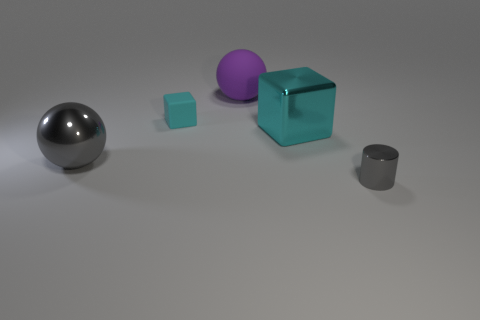Are there fewer yellow rubber balls than big objects?
Your response must be concise. Yes. There is a metal thing behind the gray metal object that is behind the small cylinder; what shape is it?
Offer a terse response. Cube. There is a small thing behind the big ball in front of the big thing that is behind the cyan rubber object; what is its shape?
Keep it short and to the point. Cube. What number of things are either tiny things left of the big purple thing or tiny objects left of the purple object?
Provide a succinct answer. 1. Is the size of the gray metallic cylinder the same as the metal thing left of the cyan matte block?
Your response must be concise. No. Is the large ball that is on the right side of the rubber block made of the same material as the cyan thing that is right of the purple matte ball?
Give a very brief answer. No. Are there an equal number of big spheres that are behind the large matte object and gray objects that are right of the small matte cube?
Provide a short and direct response. No. How many shiny cubes are the same color as the tiny rubber cube?
Make the answer very short. 1. There is a cylinder that is the same color as the big metal sphere; what is it made of?
Keep it short and to the point. Metal. What number of shiny things are either gray balls or cyan things?
Provide a short and direct response. 2. 